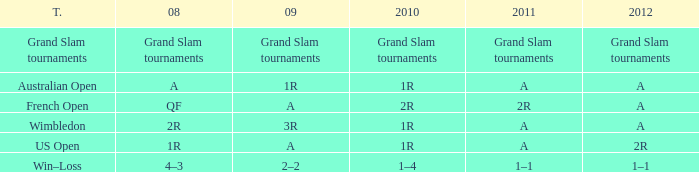Name the 2010 for 2011 of a and 2008 of 1r 1R. 